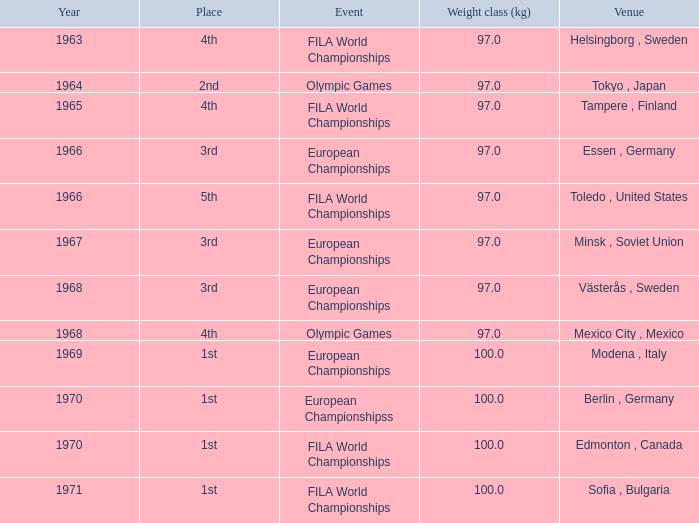What is the lowest weight class (kg) that has sofia, bulgaria as the venue? 100.0. 